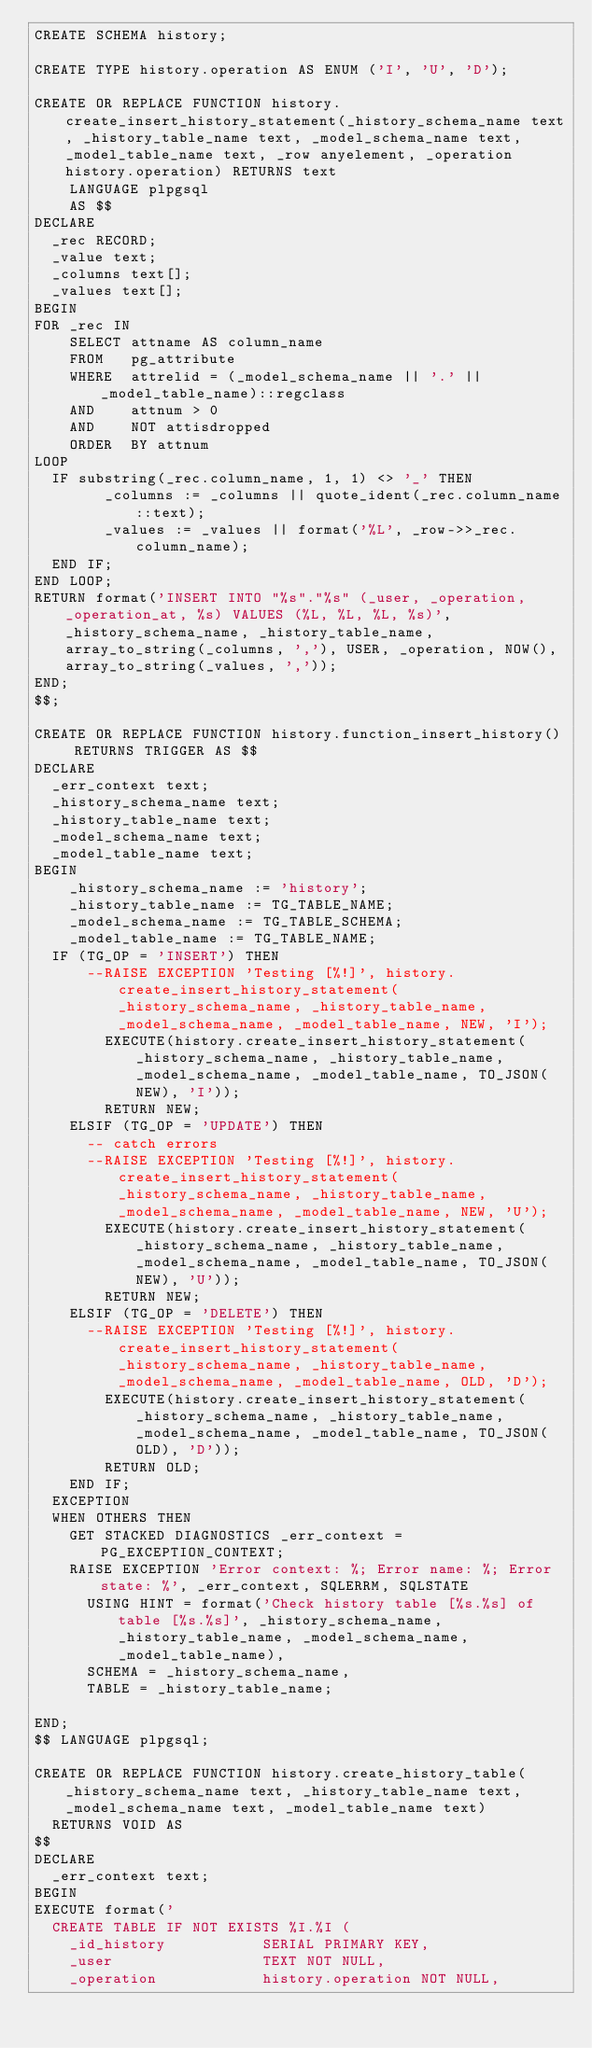Convert code to text. <code><loc_0><loc_0><loc_500><loc_500><_SQL_>CREATE SCHEMA history;

CREATE TYPE history.operation AS ENUM ('I', 'U', 'D');

CREATE OR REPLACE FUNCTION history.create_insert_history_statement(_history_schema_name text, _history_table_name text, _model_schema_name text, _model_table_name text, _row anyelement, _operation history.operation) RETURNS text
    LANGUAGE plpgsql
    AS $$
DECLARE
	_rec RECORD;
	_value text;
	_columns text[];
	_values text[];
BEGIN
FOR _rec IN
    SELECT attname AS column_name
    FROM   pg_attribute
    WHERE  attrelid = (_model_schema_name || '.' || _model_table_name)::regclass
    AND    attnum > 0
    AND    NOT attisdropped
    ORDER  BY attnum
LOOP
	IF substring(_rec.column_name, 1, 1) <> '_' THEN
        _columns := _columns || quote_ident(_rec.column_name::text);
        _values := _values || format('%L', _row->>_rec.column_name);
	END IF;
END LOOP;
RETURN format('INSERT INTO "%s"."%s" (_user, _operation, _operation_at, %s) VALUES (%L, %L, %L, %s)', _history_schema_name, _history_table_name, array_to_string(_columns, ','), USER, _operation, NOW(), array_to_string(_values, ','));
END;
$$;

CREATE OR REPLACE FUNCTION history.function_insert_history() RETURNS TRIGGER AS $$
DECLARE
  _err_context text;
  _history_schema_name text;
  _history_table_name text;
  _model_schema_name text;
  _model_table_name text;
BEGIN
    _history_schema_name := 'history';
   	_history_table_name := TG_TABLE_NAME;
  	_model_schema_name := TG_TABLE_SCHEMA;
 	  _model_table_name := TG_TABLE_NAME;
	IF (TG_OP = 'INSERT') THEN
    	--RAISE EXCEPTION 'Testing [%!]', history.create_insert_history_statement(_history_schema_name, _history_table_name, _model_schema_name, _model_table_name, NEW, 'I');
        EXECUTE(history.create_insert_history_statement(_history_schema_name, _history_table_name, _model_schema_name, _model_table_name, TO_JSON(NEW), 'I'));
        RETURN NEW;
    ELSIF (TG_OP = 'UPDATE') THEN
      -- catch errors
    	--RAISE EXCEPTION 'Testing [%!]', history.create_insert_history_statement(_history_schema_name, _history_table_name, _model_schema_name, _model_table_name, NEW, 'U');
        EXECUTE(history.create_insert_history_statement(_history_schema_name, _history_table_name, _model_schema_name, _model_table_name, TO_JSON(NEW), 'U'));
        RETURN NEW;
    ELSIF (TG_OP = 'DELETE') THEN
    	--RAISE EXCEPTION 'Testing [%!]', history.create_insert_history_statement(_history_schema_name, _history_table_name, _model_schema_name, _model_table_name, OLD, 'D');
        EXECUTE(history.create_insert_history_statement(_history_schema_name, _history_table_name, _model_schema_name, _model_table_name, TO_JSON(OLD), 'D'));
        RETURN OLD;
    END IF;
	EXCEPTION
	WHEN OTHERS THEN
	  GET STACKED DIAGNOSTICS _err_context = PG_EXCEPTION_CONTEXT;
		RAISE EXCEPTION 'Error context: %; Error name: %; Error state: %', _err_context, SQLERRM, SQLSTATE
		  USING HINT = format('Check history table [%s.%s] of table [%s.%s]', _history_schema_name, _history_table_name, _model_schema_name, _model_table_name),
		  SCHEMA = _history_schema_name,
		  TABLE = _history_table_name;

END;
$$ LANGUAGE plpgsql;

CREATE OR REPLACE FUNCTION history.create_history_table(_history_schema_name text, _history_table_name text, _model_schema_name text, _model_table_name text)
  RETURNS VOID AS
$$
DECLARE
  _err_context text;
BEGIN
EXECUTE format('
  CREATE TABLE IF NOT EXISTS %I.%I (
    _id_history           SERIAL PRIMARY KEY,
    _user                 TEXT NOT NULL,
    _operation            history.operation NOT NULL,</code> 